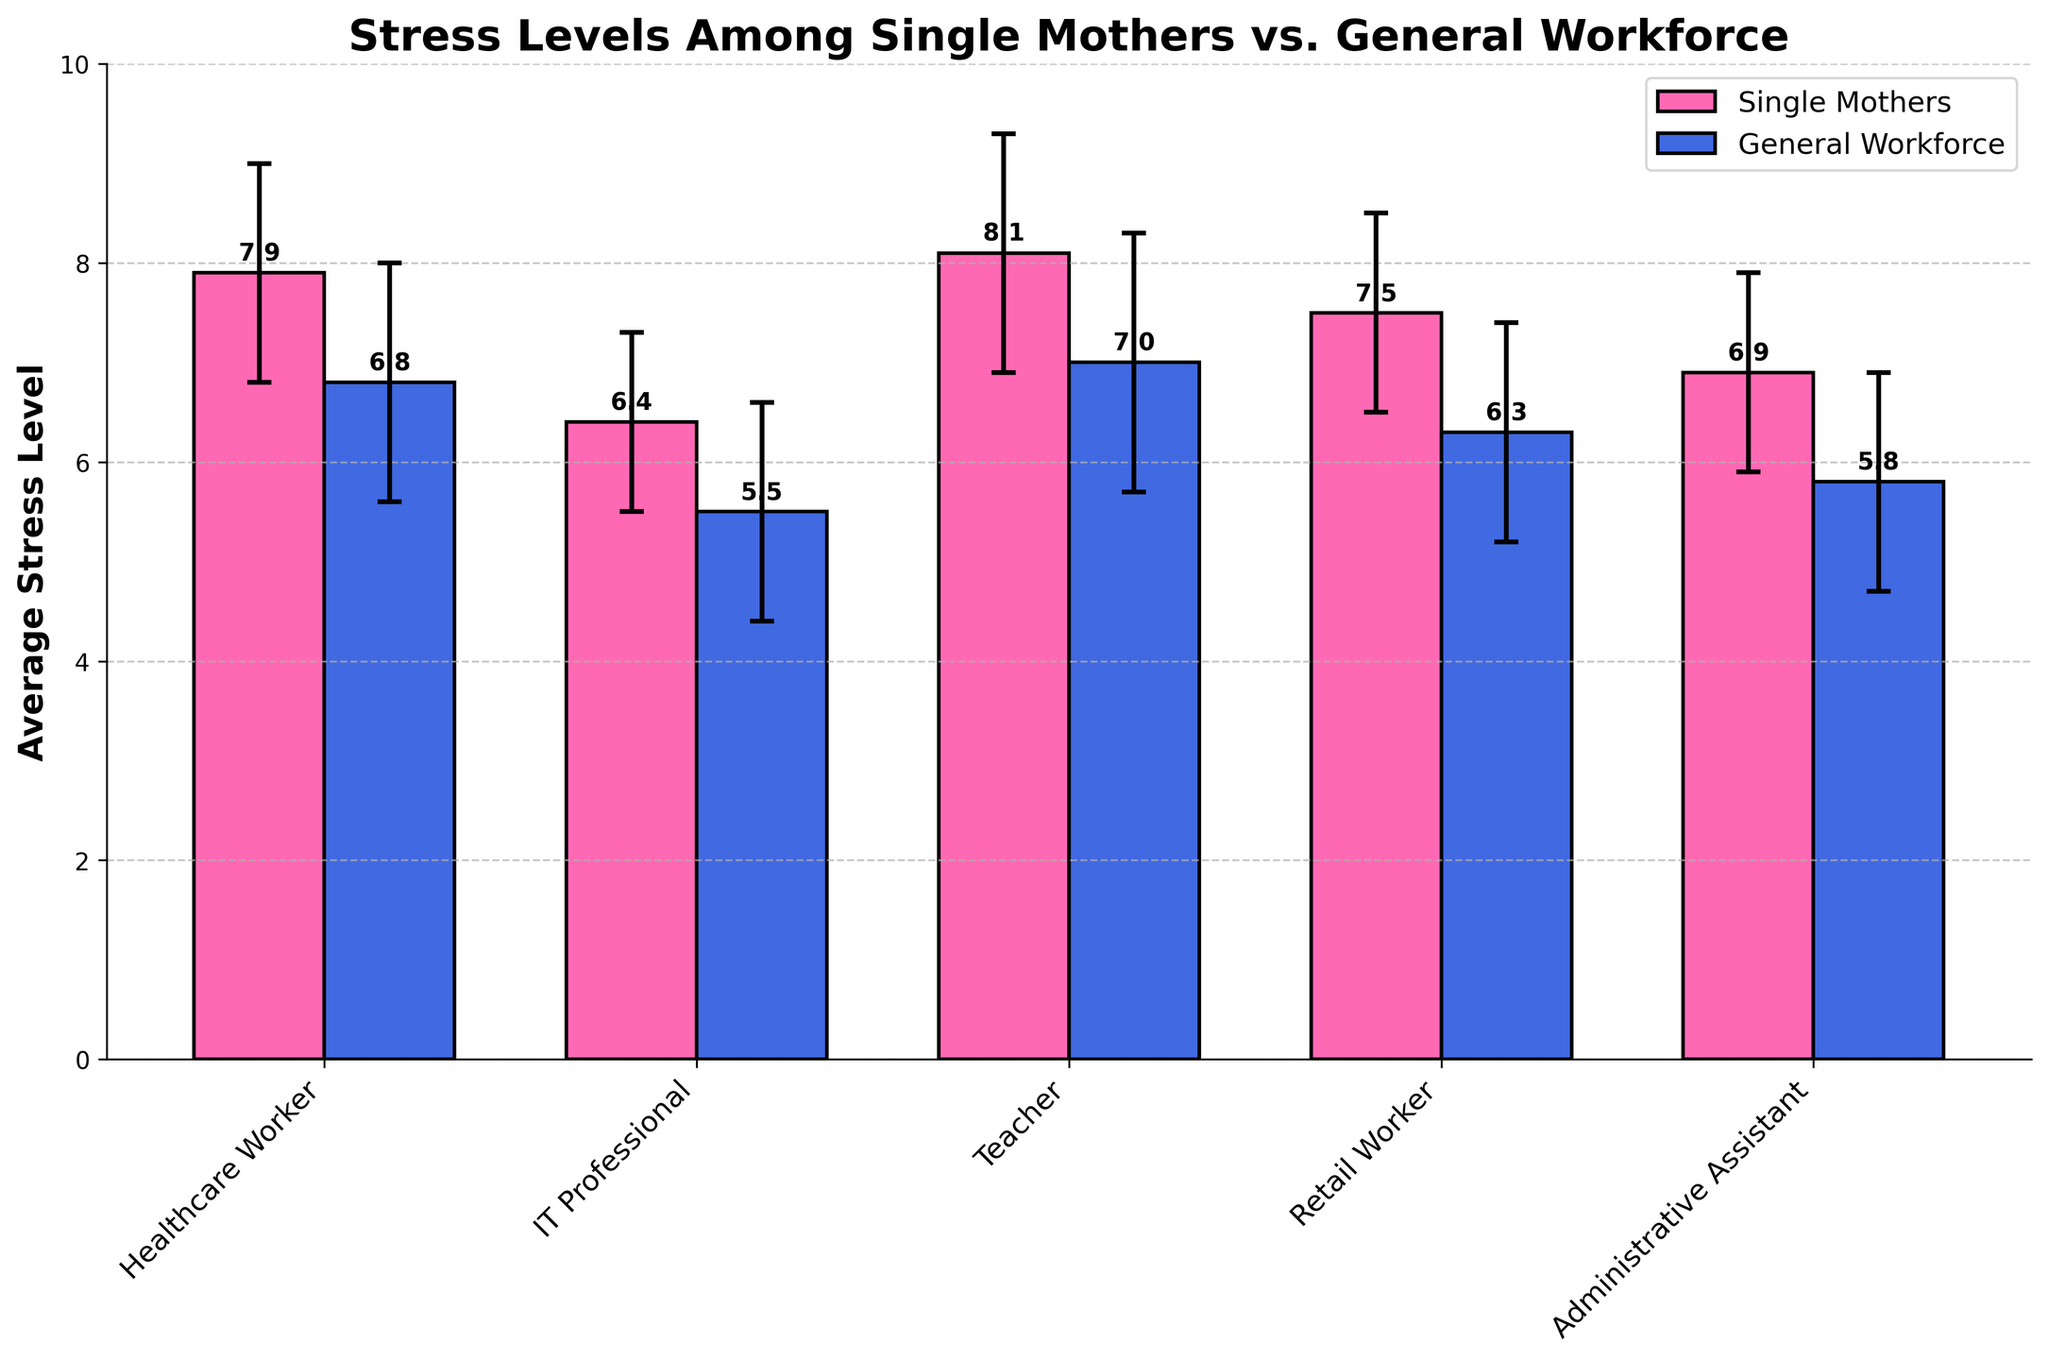what is the job role with the highest average stress level among single mothers? According to the bar heights for single mothers, 'Teacher' has the highest average stress level.
Answer: Teacher What is the difference in average stress level between single mothers and the general workforce for healthcare workers? The average stress level for single mothers in healthcare is 7.9, while it is 6.8 for the general workforce. The difference is 7.9 - 6.8 = 1.1.
Answer: 1.1 Which job role has the smallest difference in stress levels between single mothers and the general workforce? By comparing the differences for each job role: 
Healthcare Worker (1.1), IT Professional (0.9), Teacher (1.1), Retail Worker (1.2), Administrative Assistant (1.1). 'IT Professional' has the smallest difference, which is 0.9.
Answer: IT Professional Are there any job roles where single mothers have a lower average stress level than the general workforce? Looking at the plot, in all job roles, the average stress level for single mothers is higher than that of the general workforce.
Answer: No What is the average stress level for retail workers in the general workforce? The height of the blue bar (general workforce) for 'Retail Worker' indicates an average stress level of 6.3.
Answer: 6.3 Which group has smaller error bars in general, single mothers or the general workforce? The error bars for single mothers are overall shorter than those for the general workforce across most job roles, indicating that single mothers have smaller standard deviation.
Answer: Single mothers What is the overall trend in stress levels between single mothers and the general workforce across different job roles? Across all job roles, single mothers have consistently higher average stress levels than the general workforce.
Answer: Single mothers have higher stress What is the average class width in the figure? Each bar for single mothers and the general workforce is 0.35 units wide. The combined width for both groups in each job role is 0.35 + 0.35 = 0.7 units. Since there are five job roles, 0.7 * 5 = 3.5 units.
Answer: 0.7 units 